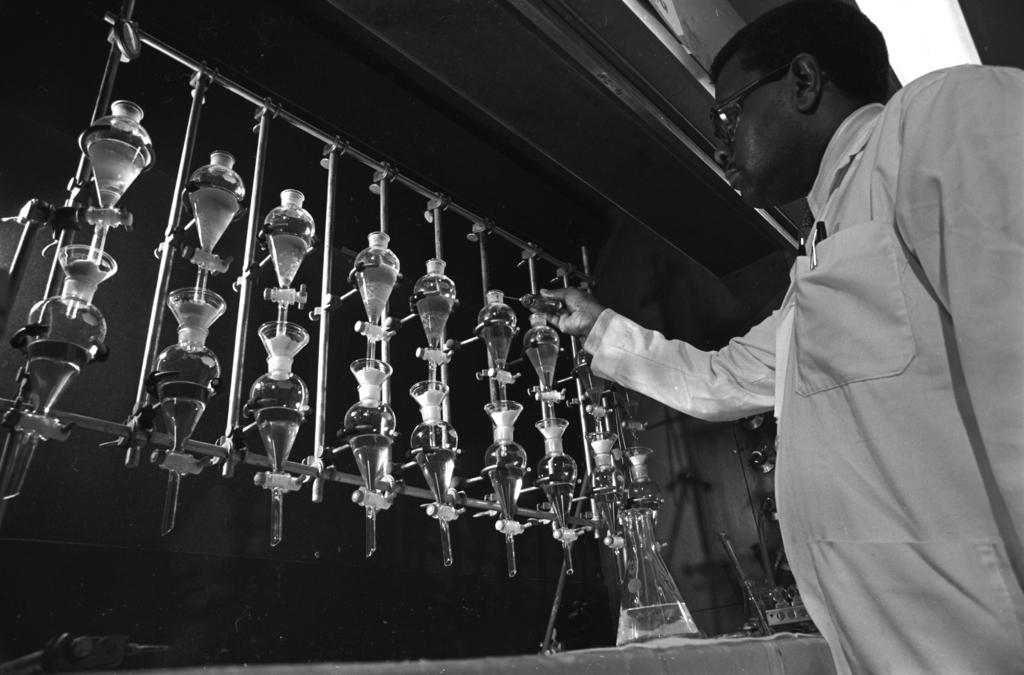What is the main subject in the foreground of the image? There is a man standing in the foreground of the image. On which side of the image is the man located? The man is on the right side of the image. What type of objects can be seen on the left side of the image? There are laboratory utensils in the image. What is the color scheme of the image? The image is in black and white. What is visible in the background of the image? There is a wall visible in the image. What type of wool is being used to create the edge of the hook in the image? There is no wool, edge, or hook present in the image. 